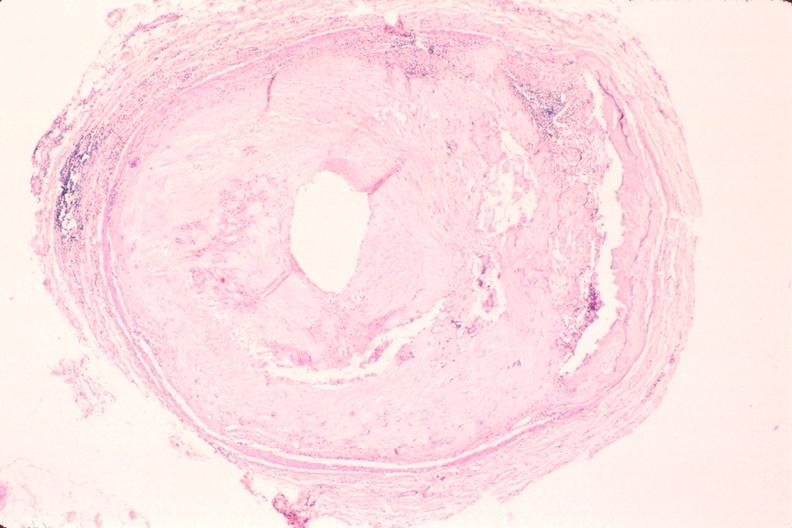s vasculature present?
Answer the question using a single word or phrase. Yes 